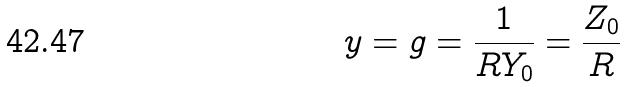Convert formula to latex. <formula><loc_0><loc_0><loc_500><loc_500>y = g = \frac { 1 } { R Y _ { 0 } } = \frac { Z _ { 0 } } { R }</formula> 